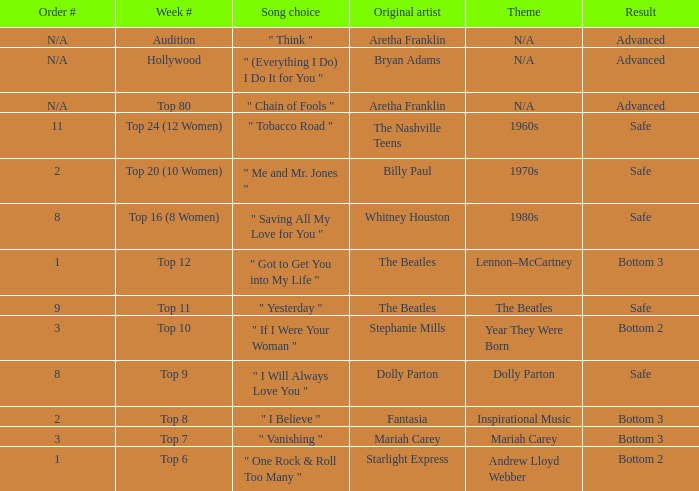Name the song choice when week number is hollywood " (Everything I Do) I Do It for You ". 